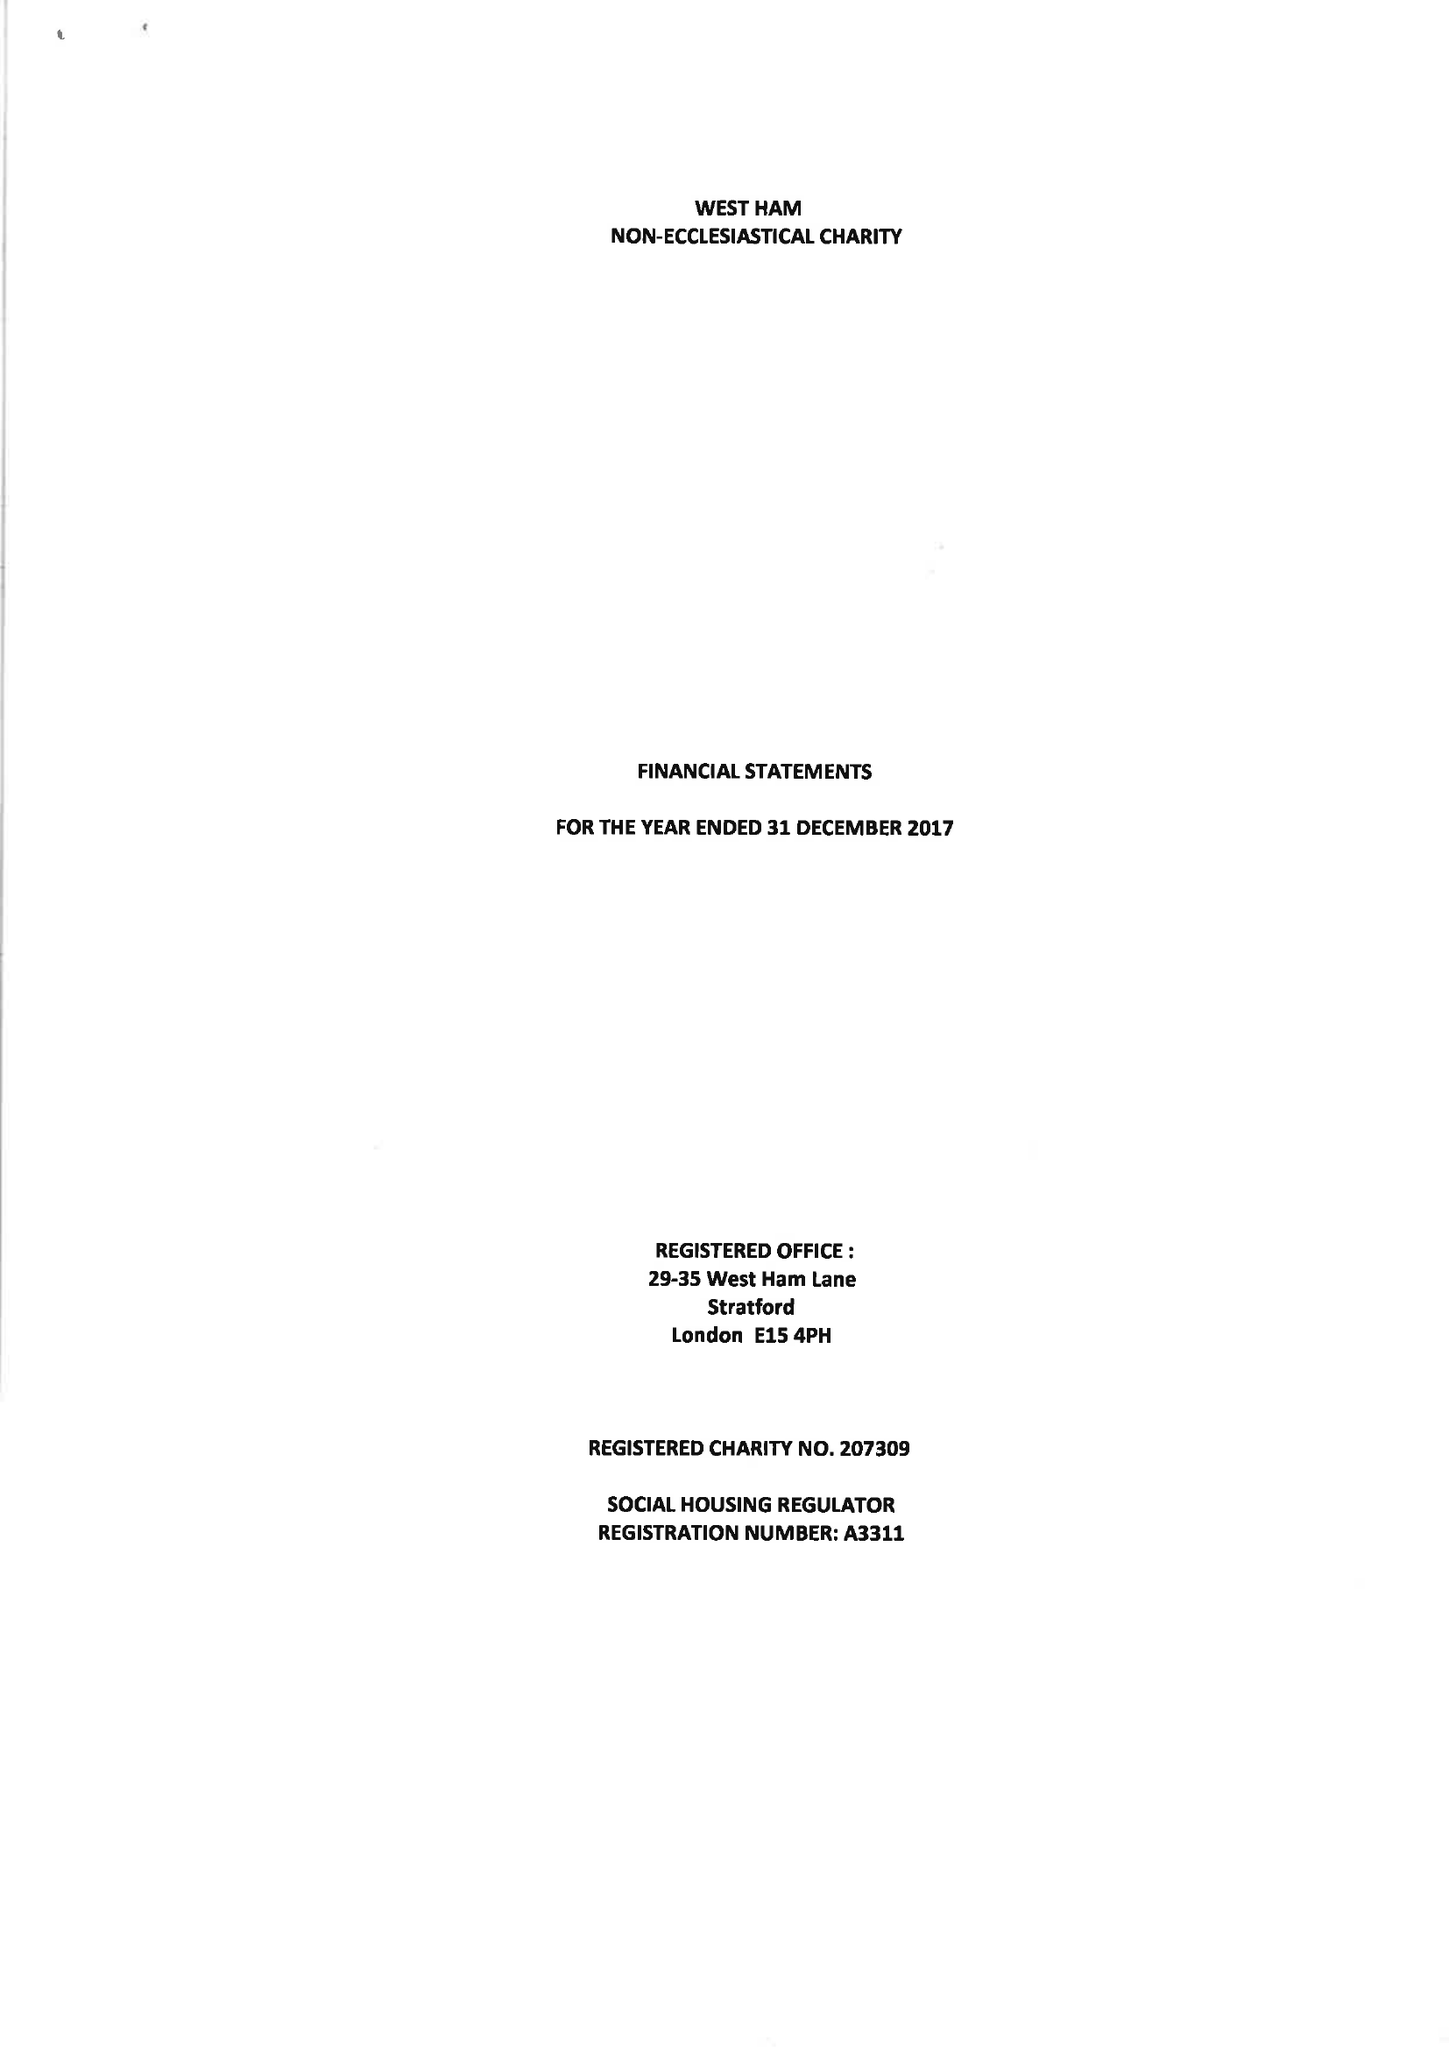What is the value for the charity_name?
Answer the question using a single word or phrase. West Ham Non-Ecclesiastical Charity 